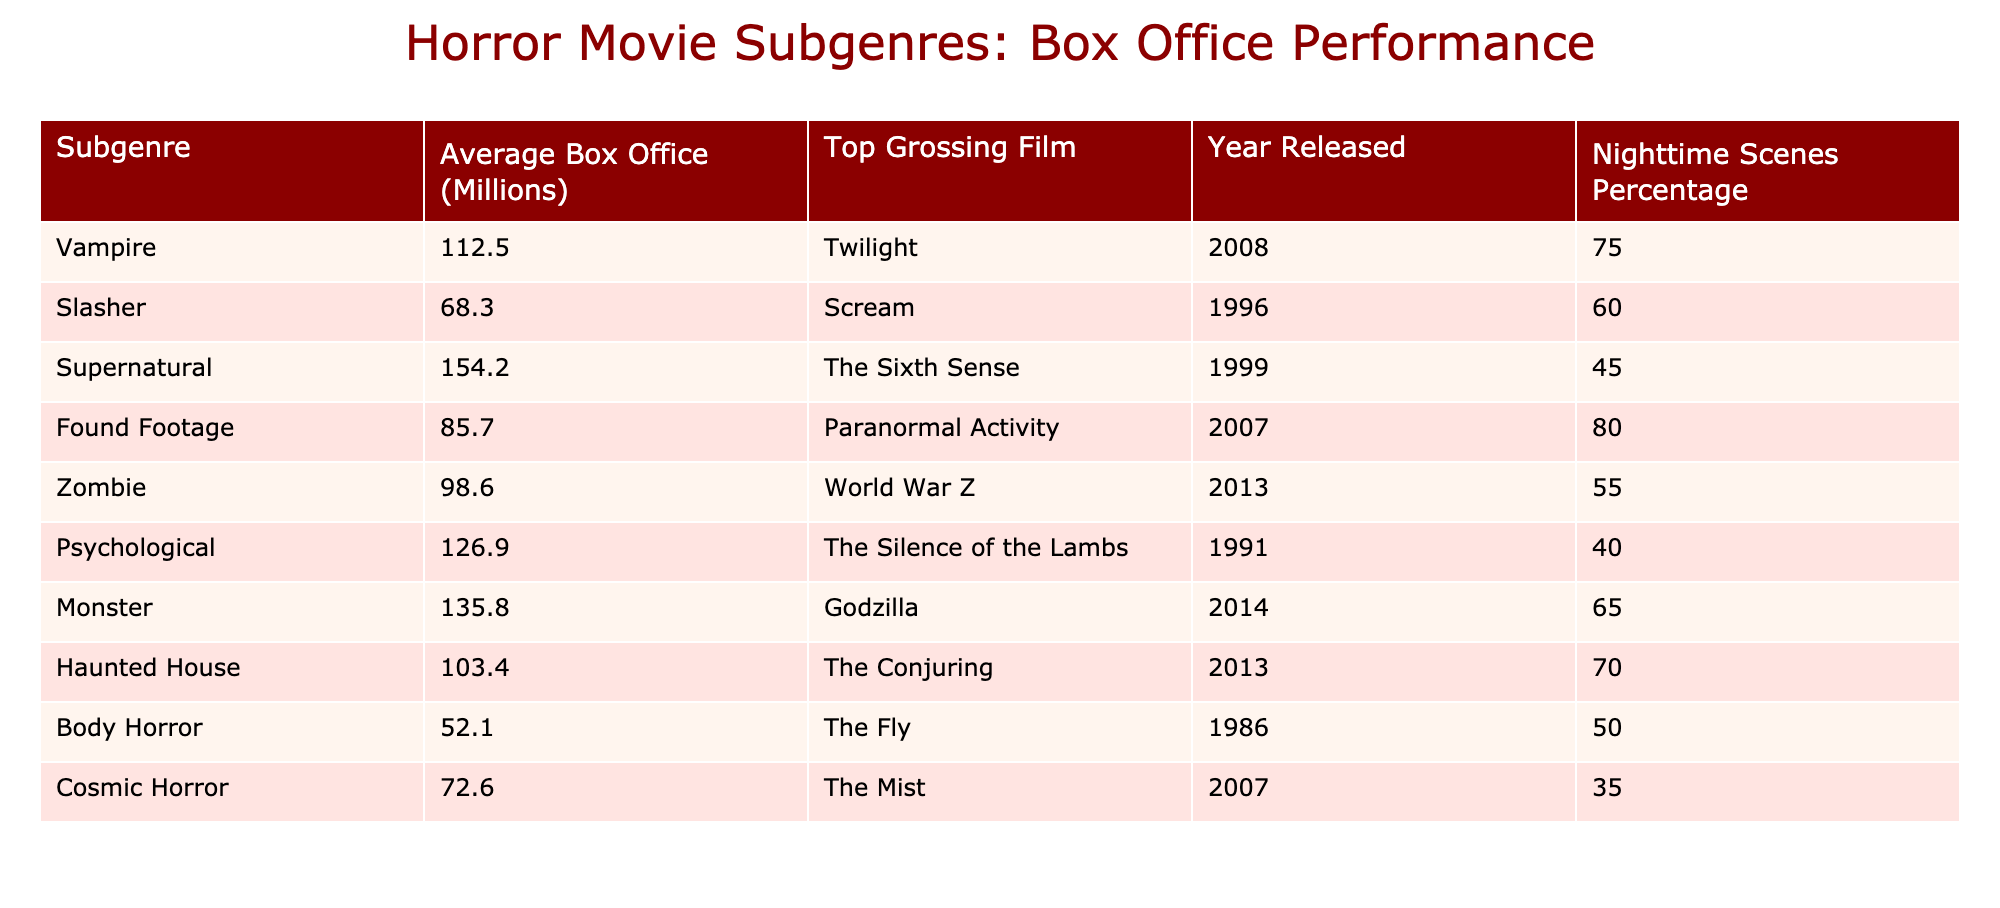What is the average box office for the vampire subgenre? The average box office for the vampire subgenre is listed in the table as 112.5 million.
Answer: 112.5 million Which subgenre has the highest average box office? The highest average box office is 154.2 million for the supernatural subgenre, as seen in the table.
Answer: Supernatural How many subgenres have an average box office above 100 million? The subgenres with average box offices above 100 million are supernatural, monster, psychological, vampire, and haunted house, making a total of 5 subgenres.
Answer: 5 Is the top-grossing film for the zombie subgenre released after 2010? The top-grossing film for the zombie subgenre is World War Z, released in 2013, which is after 2010.
Answer: Yes What is the percentage of nighttime scenes for the body horror subgenre? The percentage of nighttime scenes for the body horror subgenre is listed in the table as 50%.
Answer: 50% What is the difference in average box office performance between the slasher and found footage subgenres? The average box office for the slasher subgenre is 68.3 million and for found footage, it is 85.7 million. The difference is calculated as 85.7 - 68.3 = 17.4 million.
Answer: 17.4 million Which subgenre has the lowest average box office and what is it? The body horror subgenre has the lowest average box office of 52.1 million, as evident from the table's values.
Answer: Body Horror, 52.1 million Are there more subgenres with nighttime scenes percentage above 60% than below? The subgenres with nighttime scenes percentage above 60% are vampire (75%), found footage (80%), slasher (60%), and haunted house (70%), totaling 4. Subgenres below 60% include supernatural (45%), zombie (55%), psychological (40%), monster (65%), body horror (50%), and cosmic horror (35%), totaling 5. Therefore, there are less subgenres above 60%.
Answer: No 